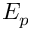Convert formula to latex. <formula><loc_0><loc_0><loc_500><loc_500>E _ { p }</formula> 